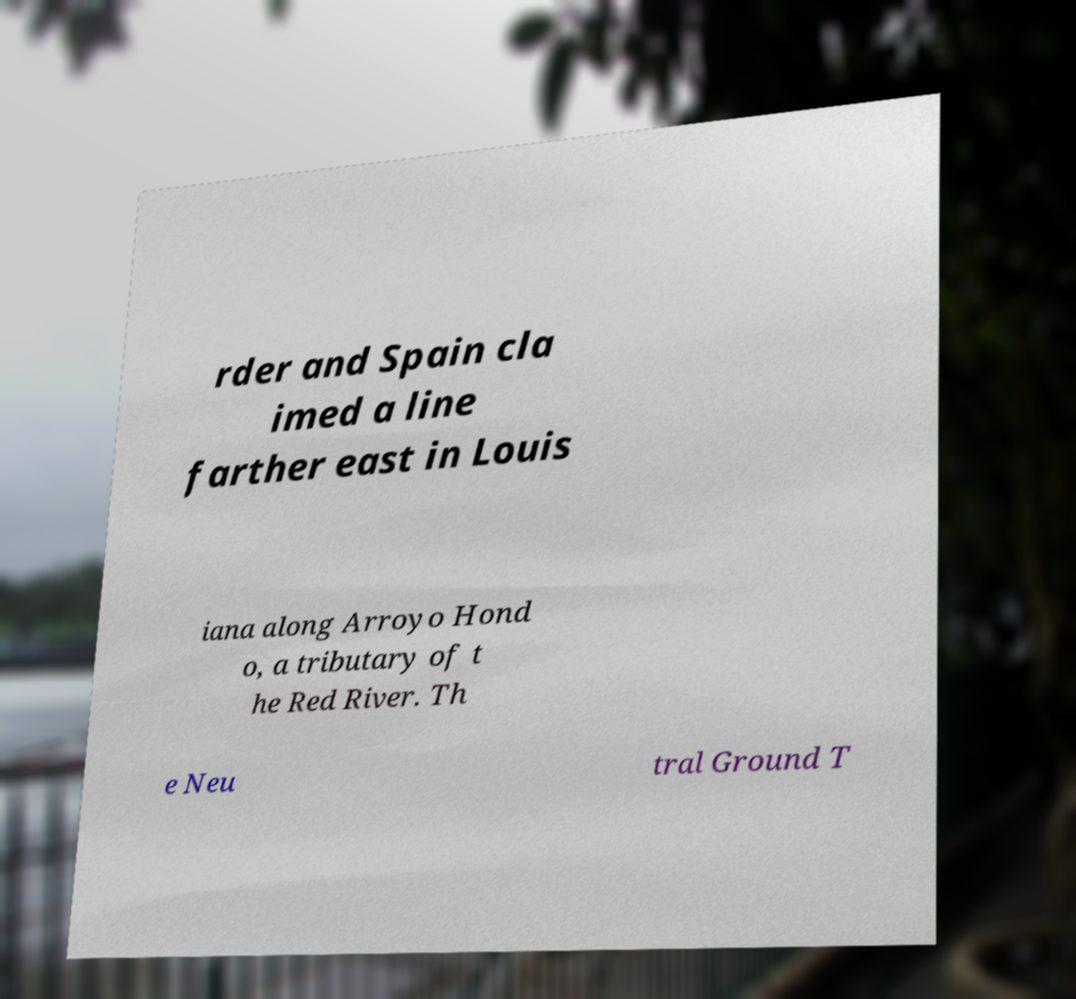What messages or text are displayed in this image? I need them in a readable, typed format. rder and Spain cla imed a line farther east in Louis iana along Arroyo Hond o, a tributary of t he Red River. Th e Neu tral Ground T 